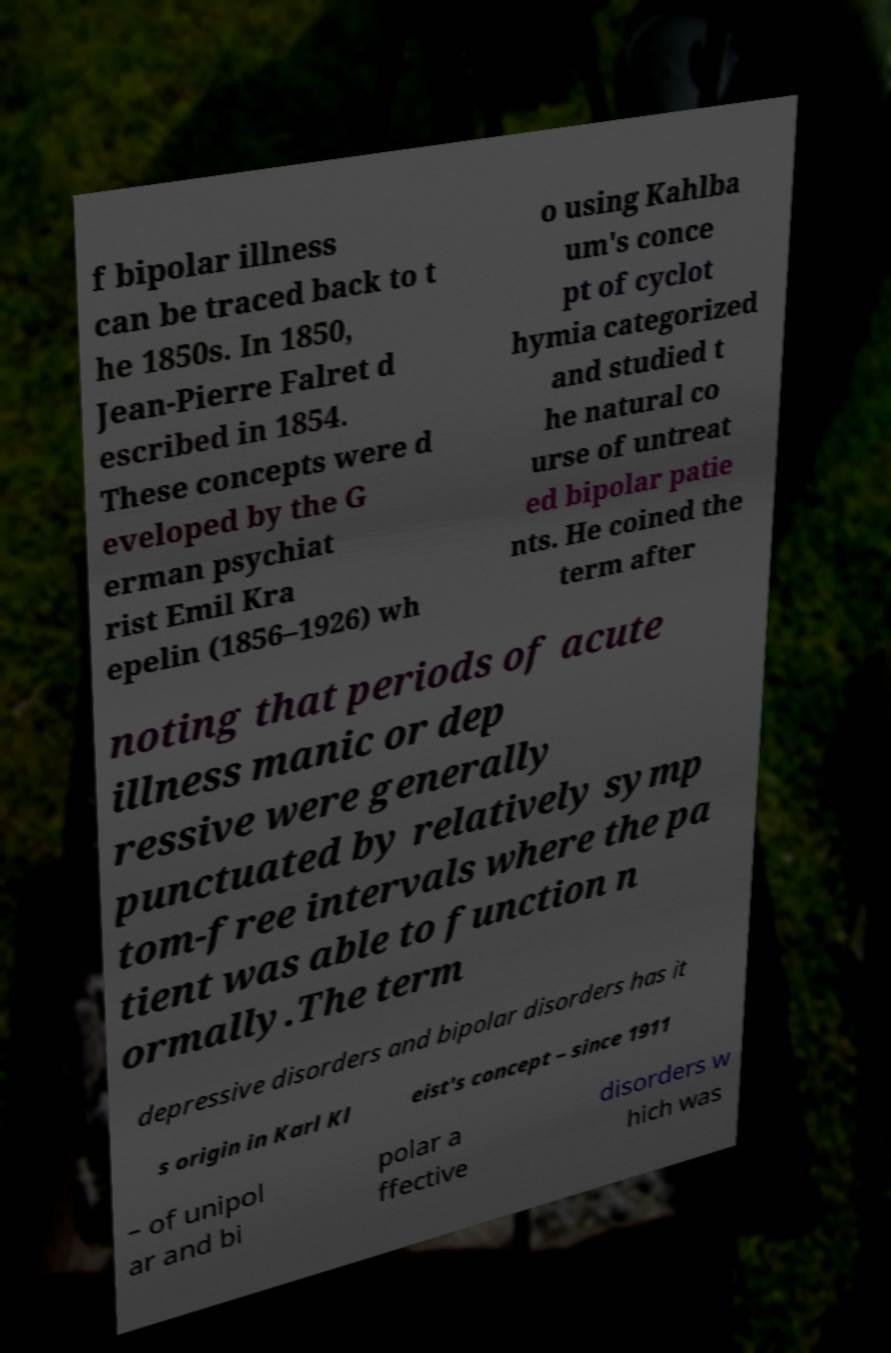Could you extract and type out the text from this image? f bipolar illness can be traced back to t he 1850s. In 1850, Jean-Pierre Falret d escribed in 1854. These concepts were d eveloped by the G erman psychiat rist Emil Kra epelin (1856–1926) wh o using Kahlba um's conce pt of cyclot hymia categorized and studied t he natural co urse of untreat ed bipolar patie nts. He coined the term after noting that periods of acute illness manic or dep ressive were generally punctuated by relatively symp tom-free intervals where the pa tient was able to function n ormally.The term depressive disorders and bipolar disorders has it s origin in Karl Kl eist's concept – since 1911 – of unipol ar and bi polar a ffective disorders w hich was 